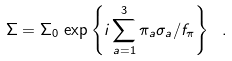<formula> <loc_0><loc_0><loc_500><loc_500>\Sigma = \Sigma _ { 0 } \, \exp \left \{ i \sum _ { a = 1 } ^ { 3 } \pi _ { a } \sigma _ { a } / f _ { \pi } \right \} \ .</formula> 